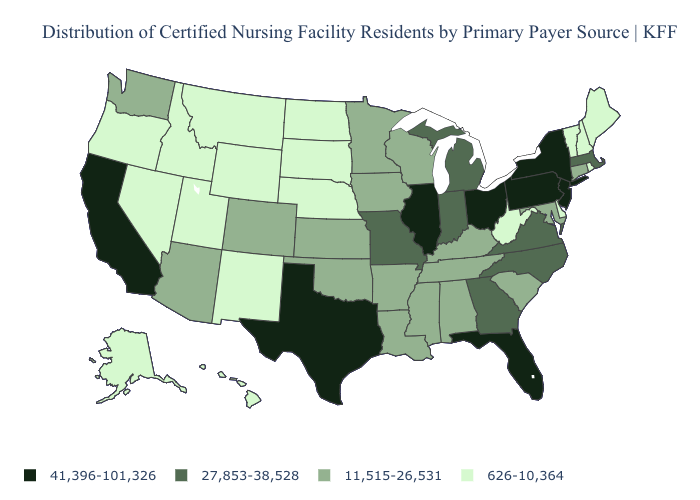What is the value of Florida?
Keep it brief. 41,396-101,326. Name the states that have a value in the range 41,396-101,326?
Concise answer only. California, Florida, Illinois, New Jersey, New York, Ohio, Pennsylvania, Texas. Does South Carolina have the same value as Idaho?
Short answer required. No. Which states have the lowest value in the USA?
Quick response, please. Alaska, Delaware, Hawaii, Idaho, Maine, Montana, Nebraska, Nevada, New Hampshire, New Mexico, North Dakota, Oregon, Rhode Island, South Dakota, Utah, Vermont, West Virginia, Wyoming. Does Texas have the highest value in the USA?
Write a very short answer. Yes. What is the value of Wyoming?
Give a very brief answer. 626-10,364. Name the states that have a value in the range 626-10,364?
Concise answer only. Alaska, Delaware, Hawaii, Idaho, Maine, Montana, Nebraska, Nevada, New Hampshire, New Mexico, North Dakota, Oregon, Rhode Island, South Dakota, Utah, Vermont, West Virginia, Wyoming. Is the legend a continuous bar?
Short answer required. No. Which states have the lowest value in the USA?
Write a very short answer. Alaska, Delaware, Hawaii, Idaho, Maine, Montana, Nebraska, Nevada, New Hampshire, New Mexico, North Dakota, Oregon, Rhode Island, South Dakota, Utah, Vermont, West Virginia, Wyoming. What is the lowest value in the USA?
Answer briefly. 626-10,364. Which states have the lowest value in the USA?
Quick response, please. Alaska, Delaware, Hawaii, Idaho, Maine, Montana, Nebraska, Nevada, New Hampshire, New Mexico, North Dakota, Oregon, Rhode Island, South Dakota, Utah, Vermont, West Virginia, Wyoming. What is the highest value in the USA?
Concise answer only. 41,396-101,326. Does North Dakota have the highest value in the MidWest?
Quick response, please. No. Name the states that have a value in the range 27,853-38,528?
Short answer required. Georgia, Indiana, Massachusetts, Michigan, Missouri, North Carolina, Virginia. Does the map have missing data?
Concise answer only. No. 